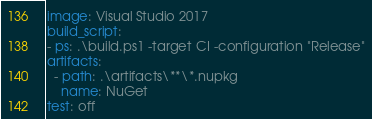<code> <loc_0><loc_0><loc_500><loc_500><_YAML_>image: Visual Studio 2017
build_script:
- ps: .\build.ps1 -target CI -configuration "Release"
artifacts:
  - path: .\artifacts\**\*.nupkg
    name: NuGet
test: off</code> 